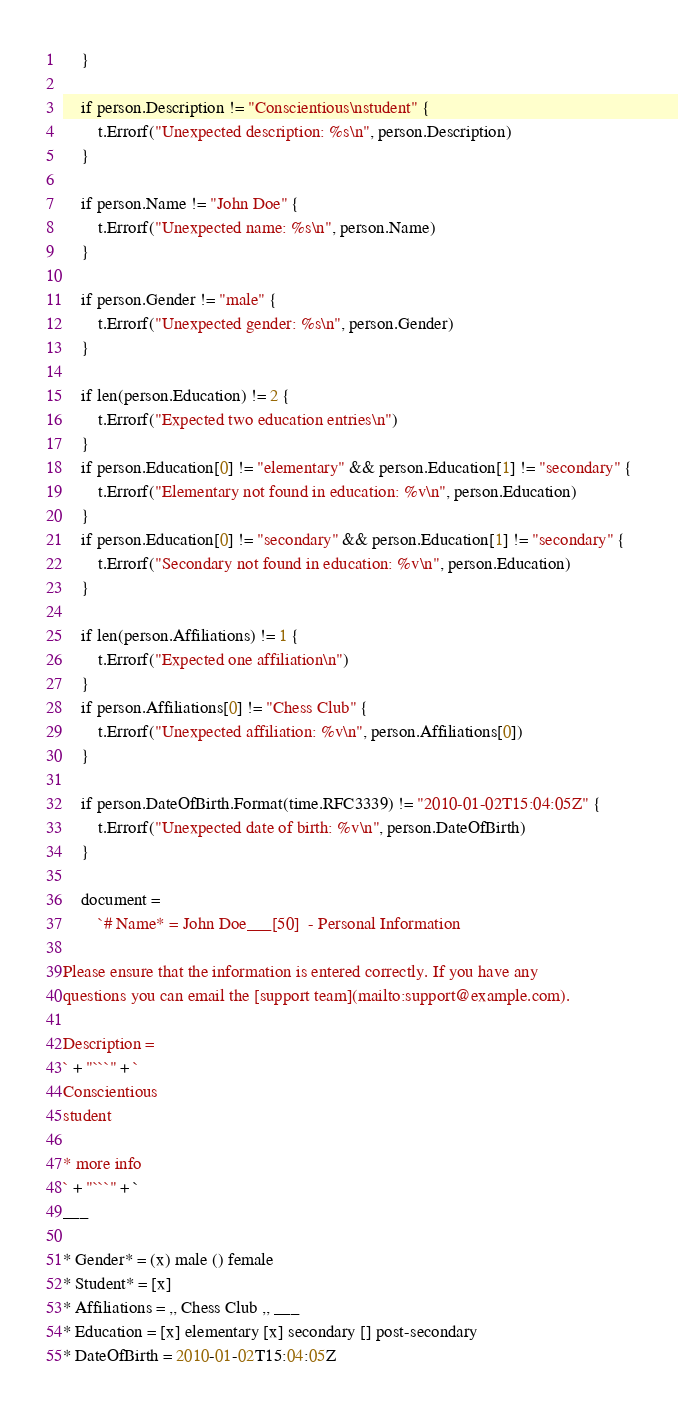<code> <loc_0><loc_0><loc_500><loc_500><_Go_>	}

	if person.Description != "Conscientious\nstudent" {
		t.Errorf("Unexpected description: %s\n", person.Description)
	}

	if person.Name != "John Doe" {
		t.Errorf("Unexpected name: %s\n", person.Name)
	}

	if person.Gender != "male" {
		t.Errorf("Unexpected gender: %s\n", person.Gender)
	}

	if len(person.Education) != 2 {
		t.Errorf("Expected two education entries\n")
	}
	if person.Education[0] != "elementary" && person.Education[1] != "secondary" {
		t.Errorf("Elementary not found in education: %v\n", person.Education)
	}
	if person.Education[0] != "secondary" && person.Education[1] != "secondary" {
		t.Errorf("Secondary not found in education: %v\n", person.Education)
	}

	if len(person.Affiliations) != 1 {
		t.Errorf("Expected one affiliation\n")
	}
	if person.Affiliations[0] != "Chess Club" {
		t.Errorf("Unexpected affiliation: %v\n", person.Affiliations[0])
	}

	if person.DateOfBirth.Format(time.RFC3339) != "2010-01-02T15:04:05Z" {
		t.Errorf("Unexpected date of birth: %v\n", person.DateOfBirth)
	}

	document =
		`# Name* = John Doe___[50]  - Personal Information

Please ensure that the information is entered correctly. If you have any
questions you can email the [support team](mailto:support@example.com).

Description = 
` + "```" + `
Conscientious
student

* more info
` + "```" + `
___

* Gender* = (x) male () female
* Student* = [x]
* Affiliations = ,, Chess Club ,, ___
* Education = [x] elementary [x] secondary [] post-secondary
* DateOfBirth = 2010-01-02T15:04:05Z
</code> 